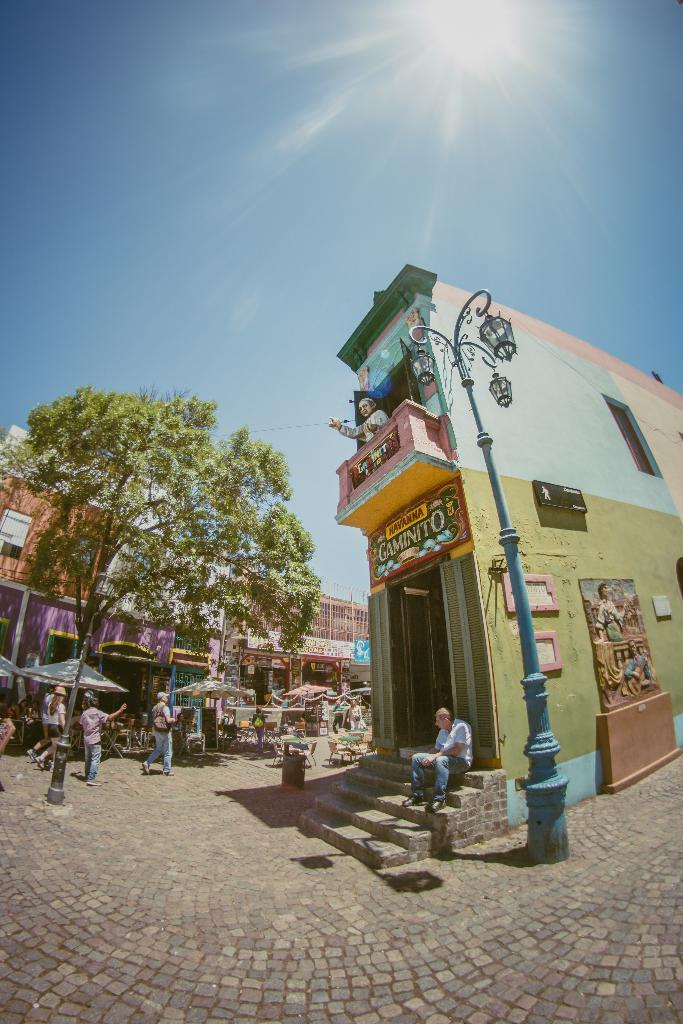How many people can be seen in the image? There are people in the image, but the exact number cannot be determined from the provided facts. What is the main feature in the image besides the people? There is a statue in the image. What other objects can be seen in the image? There are boards, a tree, poles, lights, buildings, patio umbrellas, and other objects in the image. What is visible in the background of the image? The sky is visible in the background of the image. What type of chalk is being used to draw on the boards in the image? There is no mention of chalk or any drawing activity on the boards in the image. How does the alarm system work in the image? There is no mention of an alarm system in the image. 